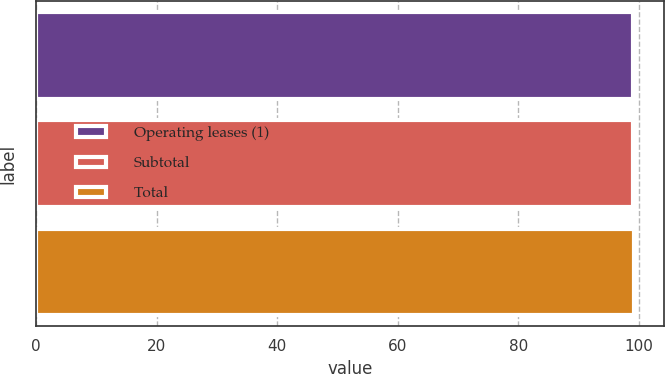<chart> <loc_0><loc_0><loc_500><loc_500><bar_chart><fcel>Operating leases (1)<fcel>Subtotal<fcel>Total<nl><fcel>99<fcel>99.1<fcel>99.2<nl></chart> 